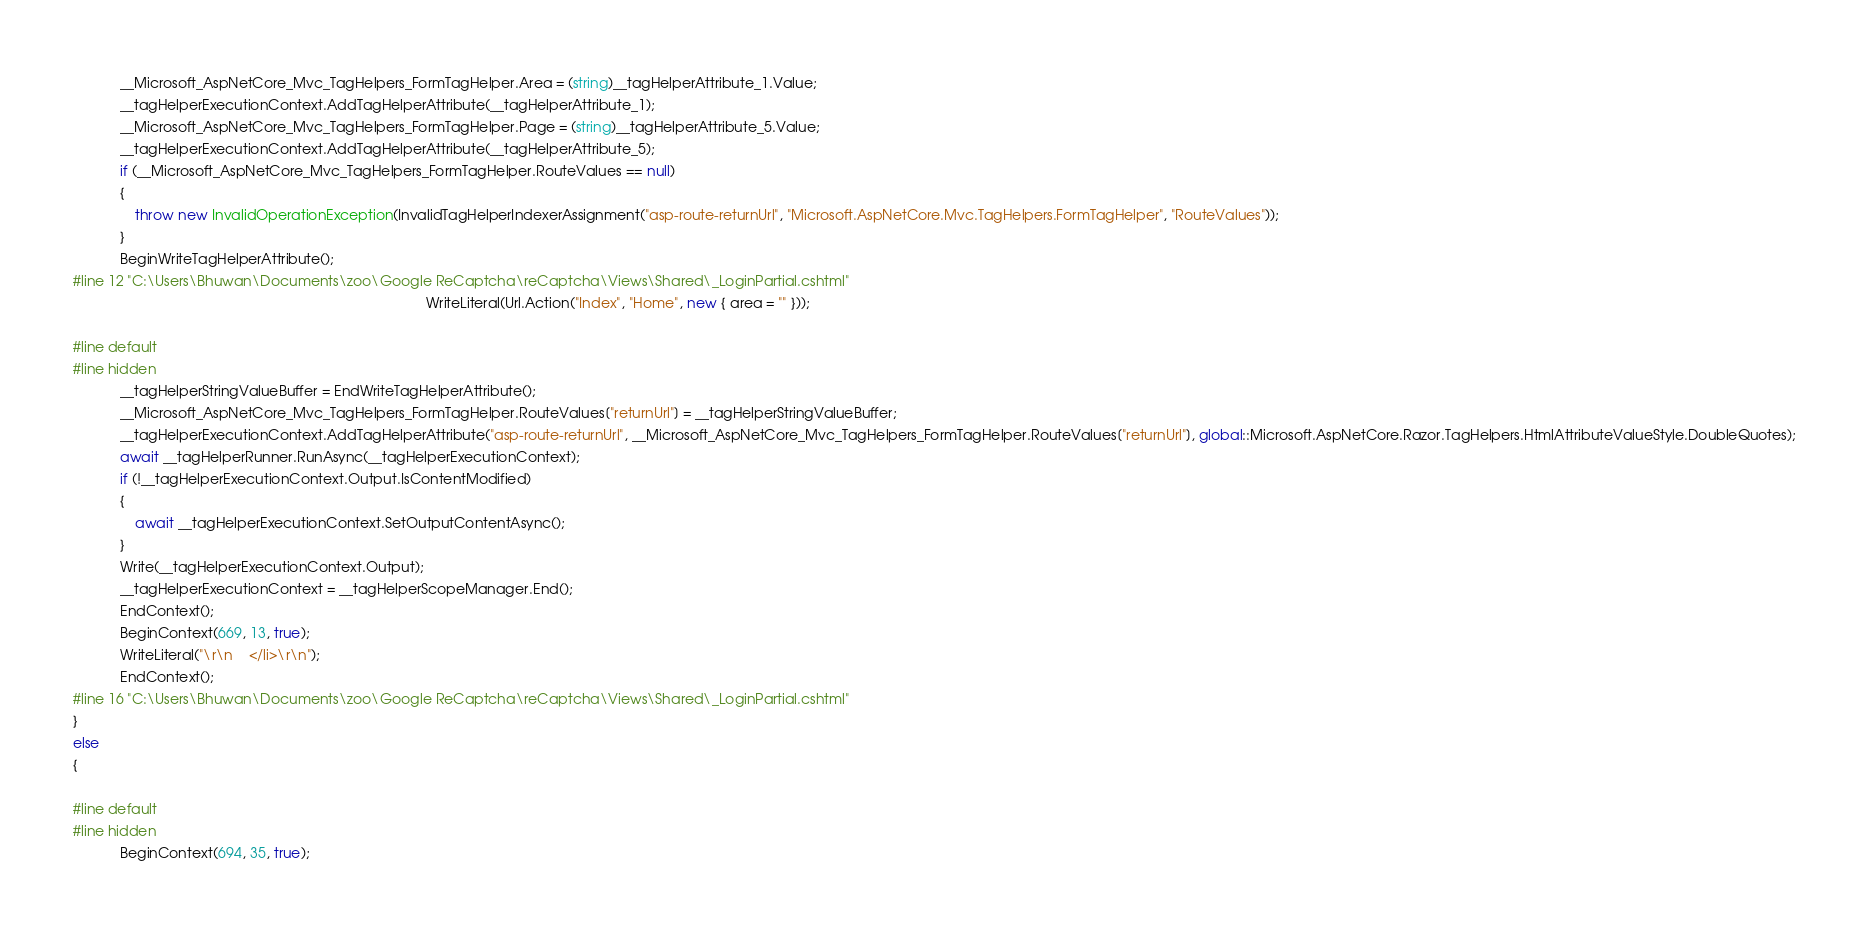<code> <loc_0><loc_0><loc_500><loc_500><_C#_>            __Microsoft_AspNetCore_Mvc_TagHelpers_FormTagHelper.Area = (string)__tagHelperAttribute_1.Value;
            __tagHelperExecutionContext.AddTagHelperAttribute(__tagHelperAttribute_1);
            __Microsoft_AspNetCore_Mvc_TagHelpers_FormTagHelper.Page = (string)__tagHelperAttribute_5.Value;
            __tagHelperExecutionContext.AddTagHelperAttribute(__tagHelperAttribute_5);
            if (__Microsoft_AspNetCore_Mvc_TagHelpers_FormTagHelper.RouteValues == null)
            {
                throw new InvalidOperationException(InvalidTagHelperIndexerAssignment("asp-route-returnUrl", "Microsoft.AspNetCore.Mvc.TagHelpers.FormTagHelper", "RouteValues"));
            }
            BeginWriteTagHelperAttribute();
#line 12 "C:\Users\Bhuwan\Documents\zoo\Google ReCaptcha\reCaptcha\Views\Shared\_LoginPartial.cshtml"
                                                                                           WriteLiteral(Url.Action("Index", "Home", new { area = "" }));

#line default
#line hidden
            __tagHelperStringValueBuffer = EndWriteTagHelperAttribute();
            __Microsoft_AspNetCore_Mvc_TagHelpers_FormTagHelper.RouteValues["returnUrl"] = __tagHelperStringValueBuffer;
            __tagHelperExecutionContext.AddTagHelperAttribute("asp-route-returnUrl", __Microsoft_AspNetCore_Mvc_TagHelpers_FormTagHelper.RouteValues["returnUrl"], global::Microsoft.AspNetCore.Razor.TagHelpers.HtmlAttributeValueStyle.DoubleQuotes);
            await __tagHelperRunner.RunAsync(__tagHelperExecutionContext);
            if (!__tagHelperExecutionContext.Output.IsContentModified)
            {
                await __tagHelperExecutionContext.SetOutputContentAsync();
            }
            Write(__tagHelperExecutionContext.Output);
            __tagHelperExecutionContext = __tagHelperScopeManager.End();
            EndContext();
            BeginContext(669, 13, true);
            WriteLiteral("\r\n    </li>\r\n");
            EndContext();
#line 16 "C:\Users\Bhuwan\Documents\zoo\Google ReCaptcha\reCaptcha\Views\Shared\_LoginPartial.cshtml"
}
else
{

#line default
#line hidden
            BeginContext(694, 35, true);</code> 